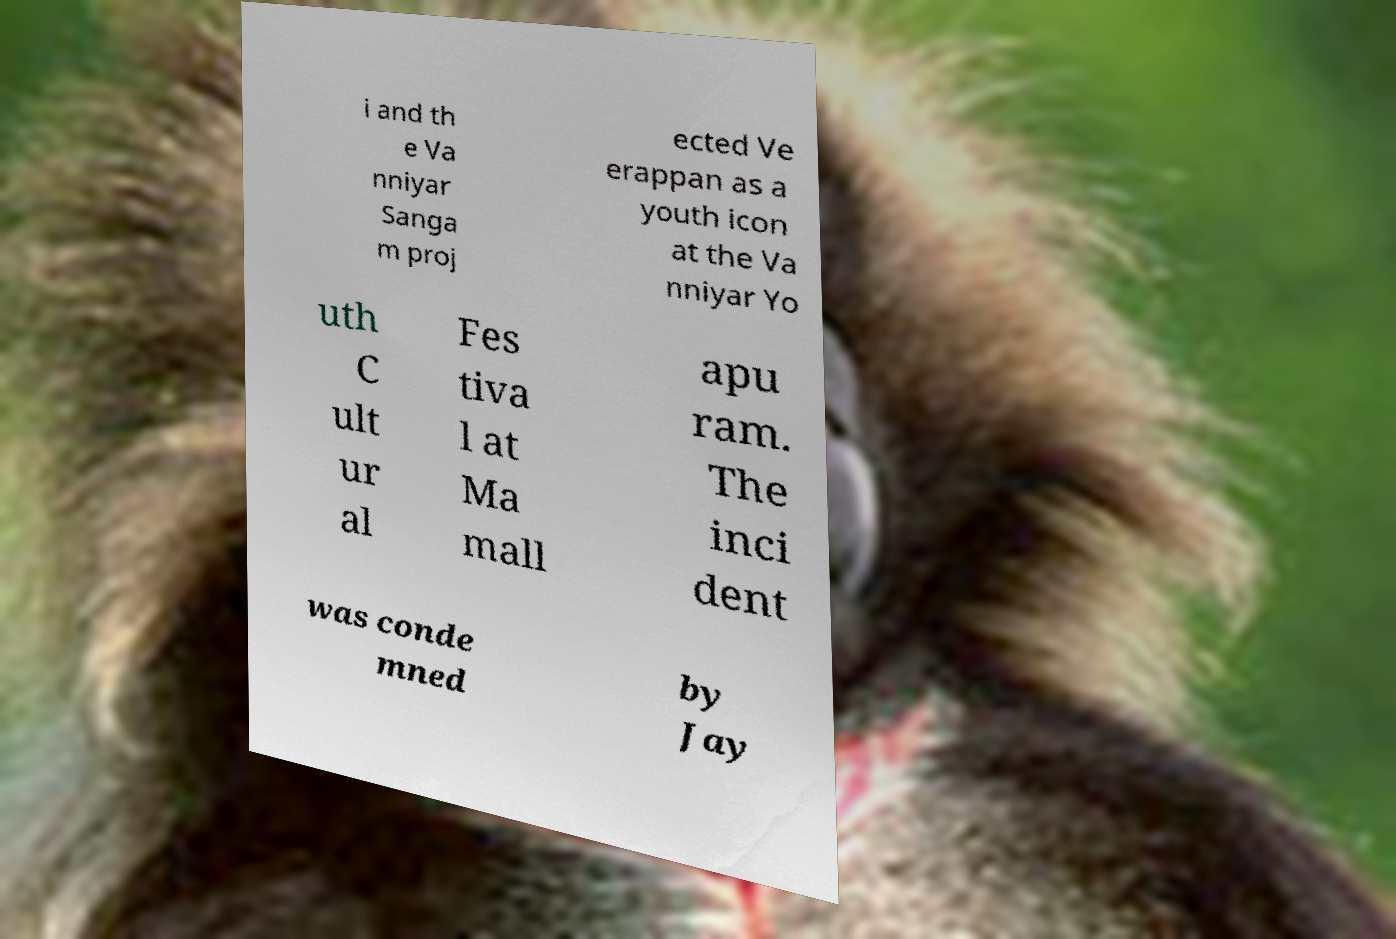For documentation purposes, I need the text within this image transcribed. Could you provide that? i and th e Va nniyar Sanga m proj ected Ve erappan as a youth icon at the Va nniyar Yo uth C ult ur al Fes tiva l at Ma mall apu ram. The inci dent was conde mned by Jay 